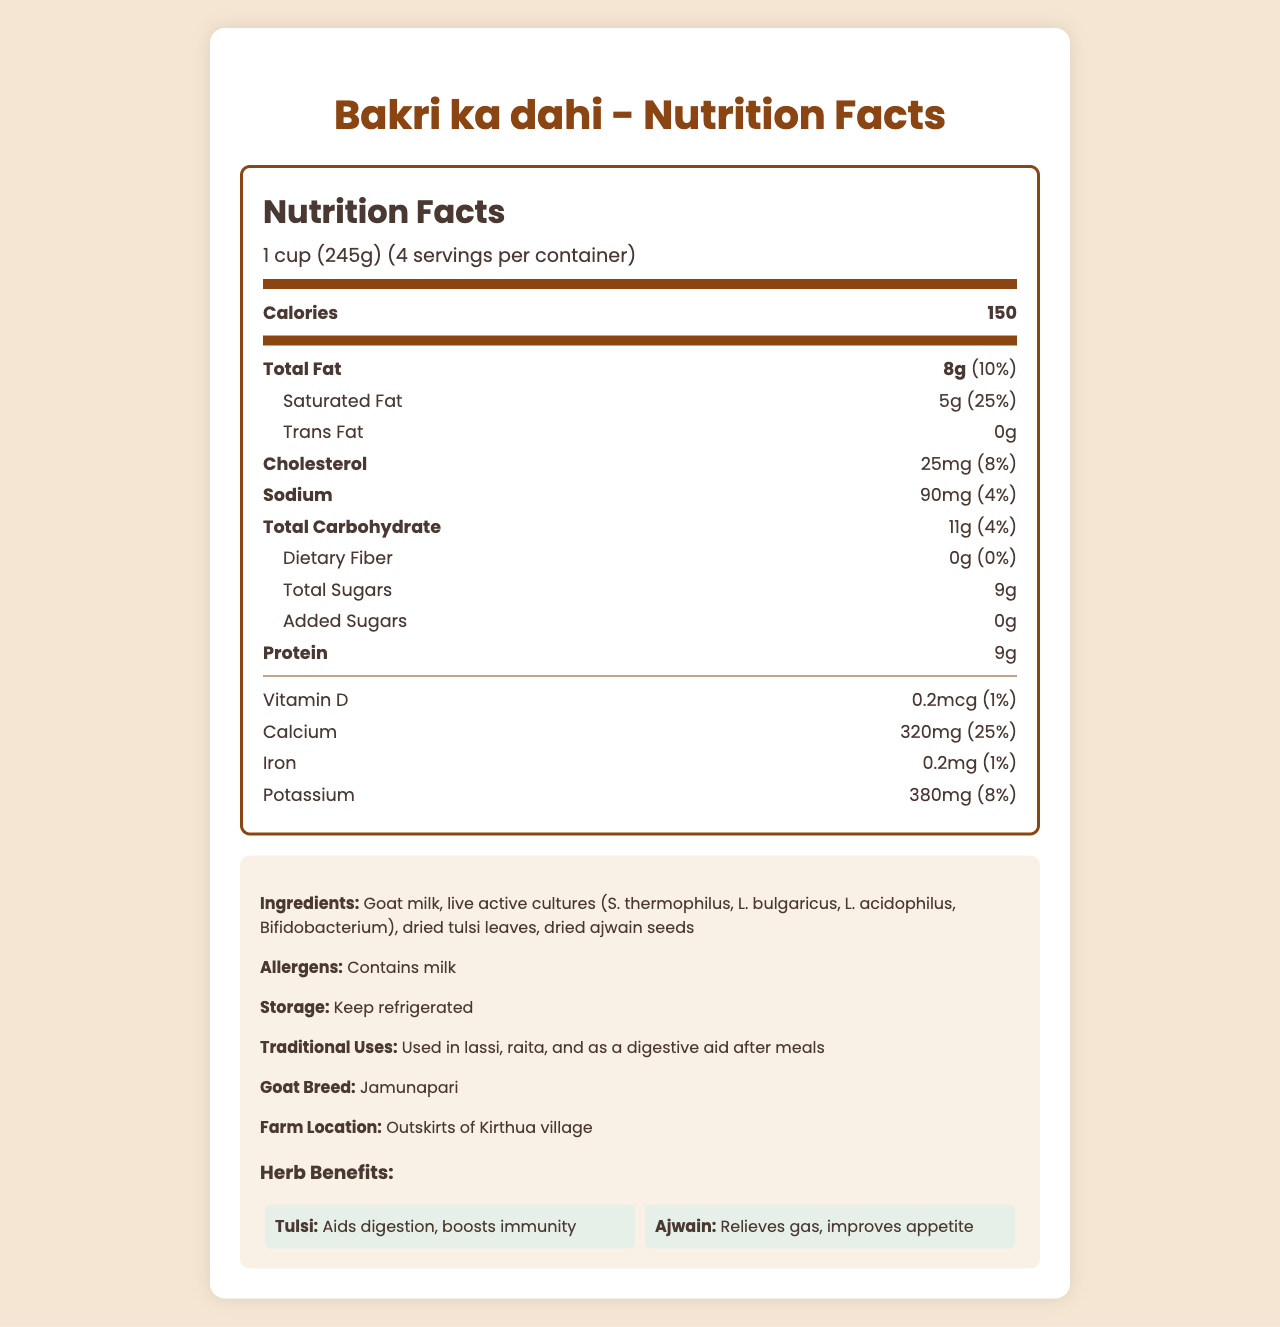What is the serving size of Bakri ka dahi? The serving size is explicitly mentioned at the top of the nutrition facts label.
Answer: 1 cup (245g) How many calories are there per serving of the yogurt? The calories per serving are clearly stated in the Nutrition Facts section of the document.
Answer: 150 What is the daily value percentage of saturated fat per serving? The daily value of saturated fat is right next to its amount in the Nutrition Facts section.
Answer: 25% Which herbs are included in the ingredients of the yogurt? The ingredients list includes the herbs tulsi and ajwain.
Answer: Dried tulsi leaves, dried ajwain seeds What is the calcium content per serving? The calcium content per serving is listed under minerals in the Nutrition Facts section.
Answer: 320mg What percentage of the daily value of sodium does one serving contain? The daily value percentage for sodium is provided in the Nutrition Facts section.
Answer: 4% How much protein is in one serving of the yogurt? A. 6g B. 9g C. 12g The protein content per serving is mentioned in the Nutrition Facts section as 9g.
Answer: B Which of the following is NOT mentioned as a benefit of tulsi? A. Aids digestion B. Boosts immunity C. Lowers cholesterol The herb benefit section indicates that tulsi aids digestion and boosts immunity but does not mention lowering cholesterol.
Answer: C Does the yogurt contain any dietary fiber? The dietary fiber amount is listed as 0g in the Nutrition Facts section.
Answer: No Summarize the main nutritional and additional information about Bakri ka dahi. The document includes nutrition facts detailing calories, fats, cholesterol, sodium, carbohydrates, and proteins, as well as additional information about ingredients, herb benefits, traditional uses, and storage instructions.
Answer: Bakri ka dahi is homemade goat milk yogurt with added herbs like dried tulsi and ajwain. It has 150 calories per serving, contains 8g total fat, 9g protein, and 11g carbohydrates. It is made from Jamunapari goat milk, contains several live cultures, and provides benefits like aiding digestion and boosting immunity from tulsi, and relieving gas and improving appetite from ajwain. The product needs to be refrigerated and is used in traditional dishes like lassi and raita. What is the exact amount of vitamin D in each serving? The exact amount of vitamin D is listed under the vitamins section in the Nutrition Facts.
Answer: 0.2mcg How should the yogurt be stored? The storage instructions are provided in the additional information section.
Answer: Keep refrigerated What breed of goat is used to make this yogurt? The goat breed is mentioned in the additional information section of the document.
Answer: Jamunapari What is the location of the farm where the goats are raised? The farm location is specified in the additional information section.
Answer: Outskirts of Kirthua village Can you determine the total cholesterol content in the entire container of yogurt? The document provides cholesterol content per serving but does not provide enough information to calculate for the entire container without additional assumptions.
Answer: Not enough information 